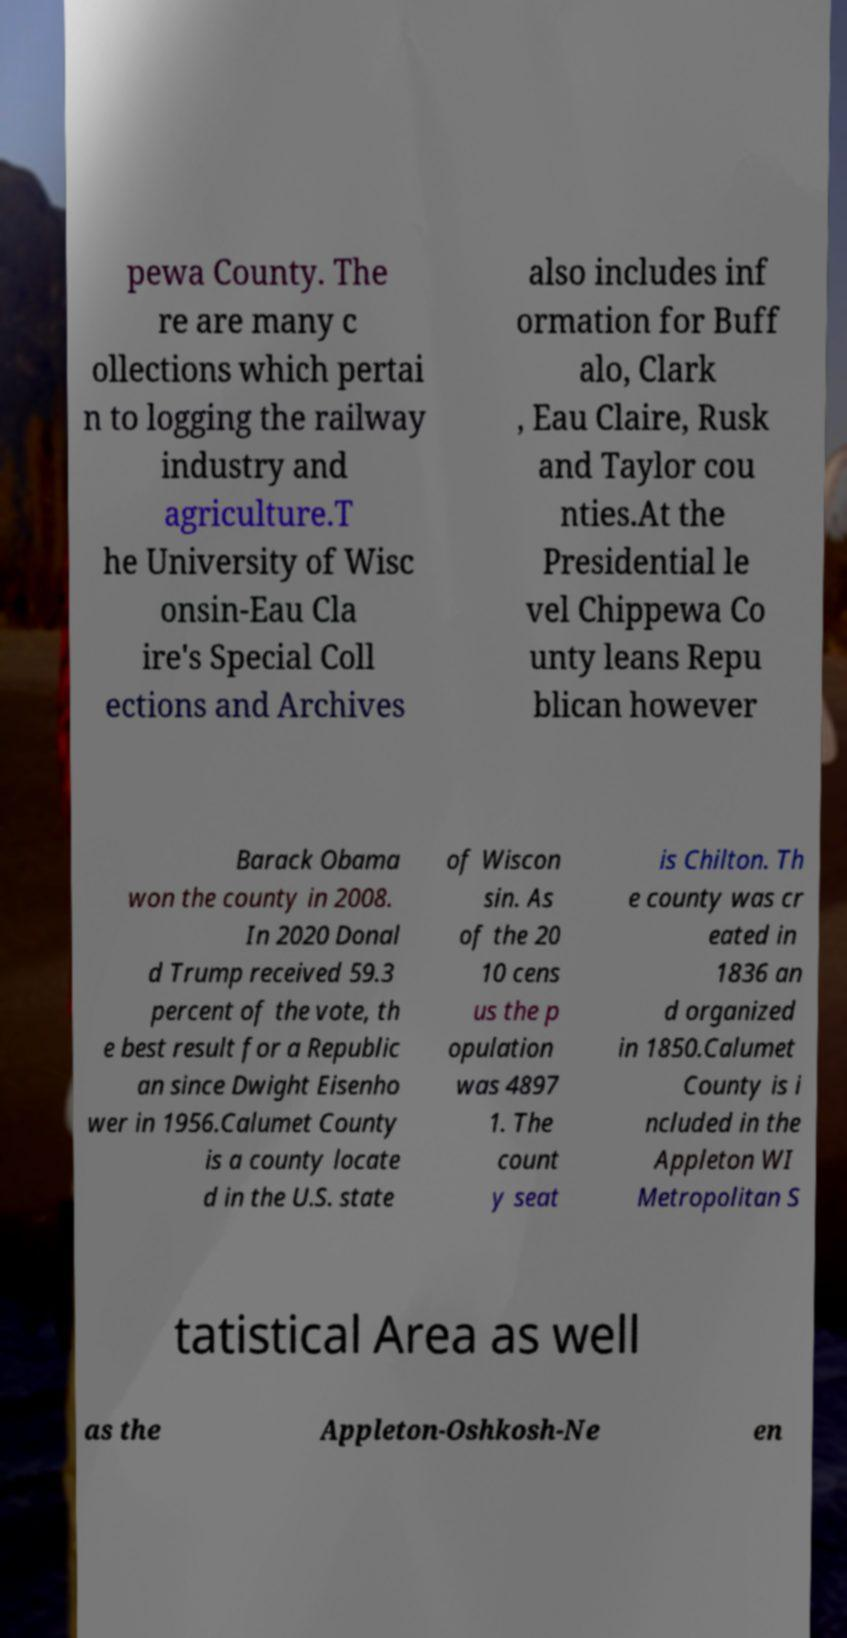There's text embedded in this image that I need extracted. Can you transcribe it verbatim? pewa County. The re are many c ollections which pertai n to logging the railway industry and agriculture.T he University of Wisc onsin-Eau Cla ire's Special Coll ections and Archives also includes inf ormation for Buff alo, Clark , Eau Claire, Rusk and Taylor cou nties.At the Presidential le vel Chippewa Co unty leans Repu blican however Barack Obama won the county in 2008. In 2020 Donal d Trump received 59.3 percent of the vote, th e best result for a Republic an since Dwight Eisenho wer in 1956.Calumet County is a county locate d in the U.S. state of Wiscon sin. As of the 20 10 cens us the p opulation was 4897 1. The count y seat is Chilton. Th e county was cr eated in 1836 an d organized in 1850.Calumet County is i ncluded in the Appleton WI Metropolitan S tatistical Area as well as the Appleton-Oshkosh-Ne en 